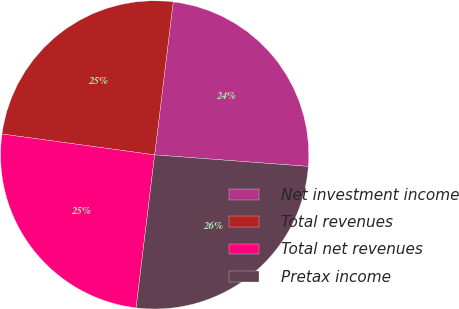Convert chart. <chart><loc_0><loc_0><loc_500><loc_500><pie_chart><fcel>Net investment income<fcel>Total revenues<fcel>Total net revenues<fcel>Pretax income<nl><fcel>24.27%<fcel>24.76%<fcel>25.24%<fcel>25.73%<nl></chart> 